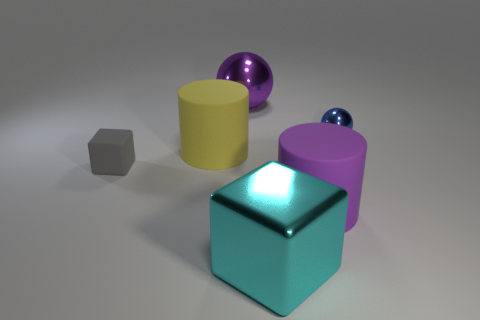Add 1 big blue cubes. How many objects exist? 7 Subtract all spheres. How many objects are left? 4 Subtract all small blue objects. Subtract all large purple rubber cylinders. How many objects are left? 4 Add 6 tiny shiny balls. How many tiny shiny balls are left? 7 Add 6 tiny gray blocks. How many tiny gray blocks exist? 7 Subtract 1 yellow cylinders. How many objects are left? 5 